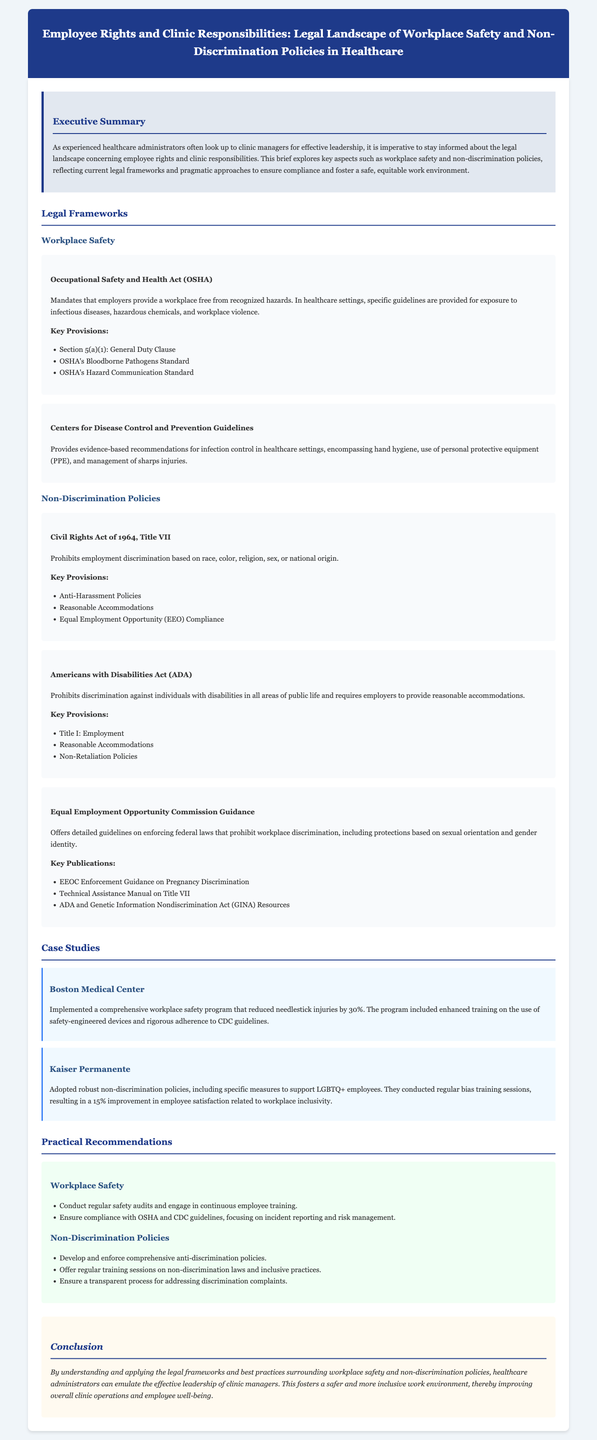what is the title of the legal brief? The title is prominently displayed in the header section of the document.
Answer: Employee Rights and Clinic Responsibilities: Legal Landscape of Workplace Safety and Non-Discrimination Policies in Healthcare what law mandates that employers provide a workplace free from recognized hazards? This law is discussed under the Workplace Safety section as a key framework for healthcare settings.
Answer: Occupational Safety and Health Act (OSHA) which organization provides guidelines for infection control in healthcare settings? The organization is referenced in the Workplace Safety section regarding safety recommendations.
Answer: Centers for Disease Control and Prevention what year was the Civil Rights Act enacted? The Act is referenced under the Non-Discrimination Policies section, highlighting a significant legal framework.
Answer: 1964 what percentage reduction in needlestick injuries did Boston Medical Center achieve? The case study details the effectiveness of their implemented safety program.
Answer: 30% what are the two major titles under the Americans with Disabilities Act (ADA)? The major titles are mentioned in the section on Non-Discrimination policies referencing the Act's provisions.
Answer: Title I and Reasonable Accommodations how often should safety audits be conducted according to the recommendations? The recommendations imply the frequency of audits and continuous training practices for effective safety measures.
Answer: Regularly what is the focus of Kaiser Permanente's non-discrimination policies? The focus is identified in the case study related to inclusive practices for employees.
Answer: LGBTQ+ employees what does the recommendation for addressing discrimination complaints suggest? The recommendation stresses the importance of how complaints should be handled in a transparent manner.
Answer: Transparent process 